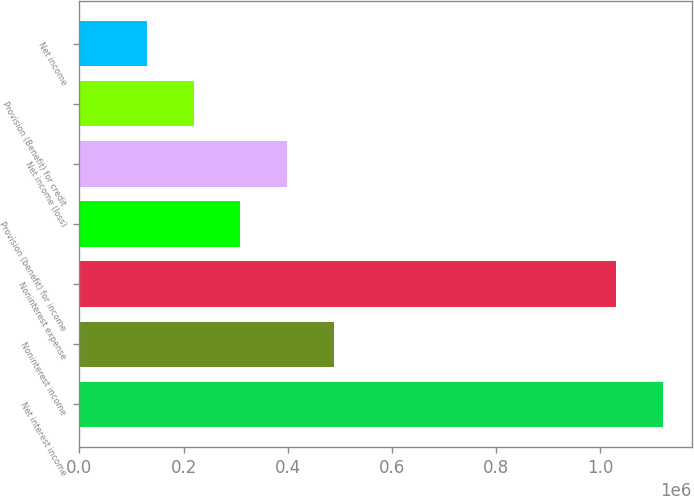<chart> <loc_0><loc_0><loc_500><loc_500><bar_chart><fcel>Net interest income<fcel>Noninterest income<fcel>Noninterest expense<fcel>Provision (benefit) for income<fcel>Net income (loss)<fcel>Provision (Benefit) for credit<fcel>Net income<nl><fcel>1.11985e+06<fcel>489479<fcel>1.02973e+06<fcel>309226<fcel>399352<fcel>219100<fcel>128973<nl></chart> 